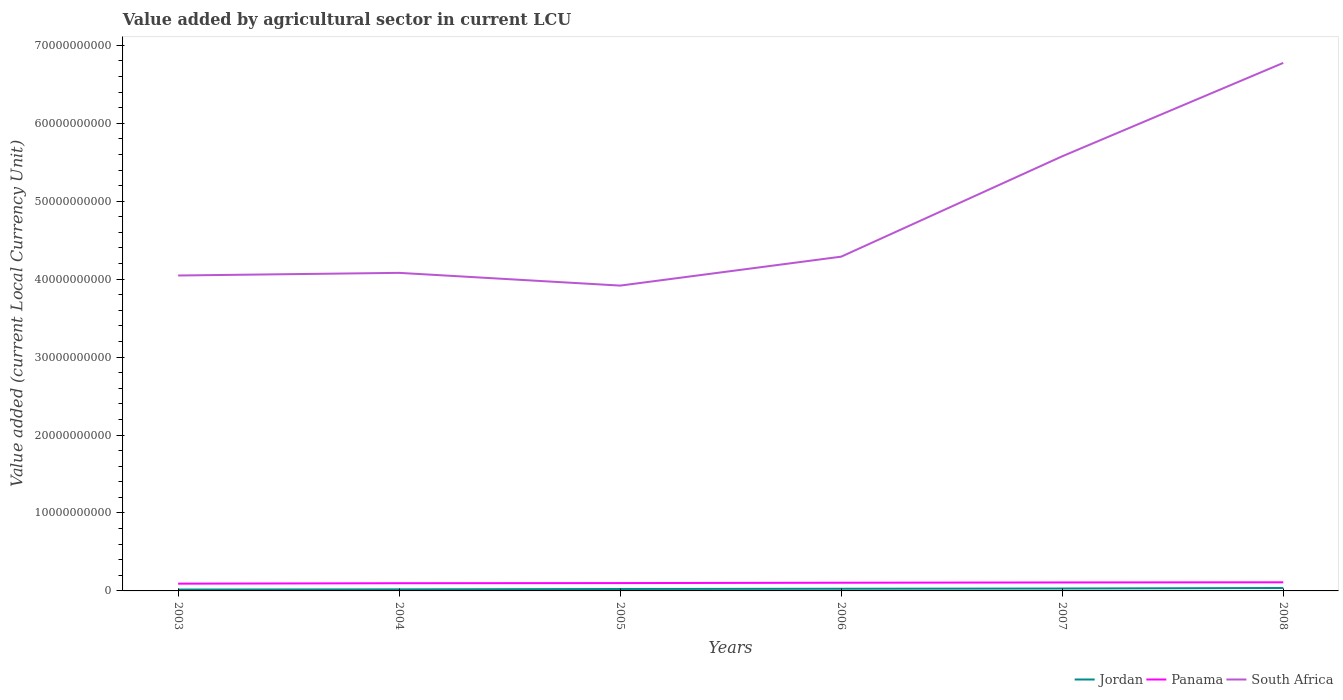Is the number of lines equal to the number of legend labels?
Make the answer very short. Yes. Across all years, what is the maximum value added by agricultural sector in South Africa?
Ensure brevity in your answer.  3.92e+1. What is the total value added by agricultural sector in Panama in the graph?
Your answer should be very brief. -1.77e+08. What is the difference between the highest and the second highest value added by agricultural sector in South Africa?
Provide a succinct answer. 2.86e+1. What is the difference between the highest and the lowest value added by agricultural sector in Panama?
Offer a very short reply. 3. How many years are there in the graph?
Provide a short and direct response. 6. What is the difference between two consecutive major ticks on the Y-axis?
Offer a terse response. 1.00e+1. Does the graph contain any zero values?
Ensure brevity in your answer.  No. Does the graph contain grids?
Keep it short and to the point. No. Where does the legend appear in the graph?
Give a very brief answer. Bottom right. How are the legend labels stacked?
Ensure brevity in your answer.  Horizontal. What is the title of the graph?
Ensure brevity in your answer.  Value added by agricultural sector in current LCU. What is the label or title of the Y-axis?
Keep it short and to the point. Value added (current Local Currency Unit). What is the Value added (current Local Currency Unit) in Jordan in 2003?
Provide a succinct answer. 1.78e+08. What is the Value added (current Local Currency Unit) of Panama in 2003?
Give a very brief answer. 9.30e+08. What is the Value added (current Local Currency Unit) in South Africa in 2003?
Keep it short and to the point. 4.05e+1. What is the Value added (current Local Currency Unit) in Jordan in 2004?
Provide a short and direct response. 2.02e+08. What is the Value added (current Local Currency Unit) of Panama in 2004?
Keep it short and to the point. 9.88e+08. What is the Value added (current Local Currency Unit) of South Africa in 2004?
Provide a short and direct response. 4.08e+1. What is the Value added (current Local Currency Unit) in Jordan in 2005?
Provide a short and direct response. 2.46e+08. What is the Value added (current Local Currency Unit) in Panama in 2005?
Your answer should be compact. 1.01e+09. What is the Value added (current Local Currency Unit) in South Africa in 2005?
Make the answer very short. 3.92e+1. What is the Value added (current Local Currency Unit) of Jordan in 2006?
Your answer should be compact. 2.76e+08. What is the Value added (current Local Currency Unit) of Panama in 2006?
Make the answer very short. 1.05e+09. What is the Value added (current Local Currency Unit) of South Africa in 2006?
Provide a succinct answer. 4.29e+1. What is the Value added (current Local Currency Unit) in Jordan in 2007?
Provide a succinct answer. 3.07e+08. What is the Value added (current Local Currency Unit) of Panama in 2007?
Give a very brief answer. 1.09e+09. What is the Value added (current Local Currency Unit) of South Africa in 2007?
Your answer should be very brief. 5.58e+1. What is the Value added (current Local Currency Unit) of Jordan in 2008?
Keep it short and to the point. 3.77e+08. What is the Value added (current Local Currency Unit) of Panama in 2008?
Ensure brevity in your answer.  1.11e+09. What is the Value added (current Local Currency Unit) in South Africa in 2008?
Your response must be concise. 6.77e+1. Across all years, what is the maximum Value added (current Local Currency Unit) of Jordan?
Ensure brevity in your answer.  3.77e+08. Across all years, what is the maximum Value added (current Local Currency Unit) in Panama?
Make the answer very short. 1.11e+09. Across all years, what is the maximum Value added (current Local Currency Unit) in South Africa?
Your response must be concise. 6.77e+1. Across all years, what is the minimum Value added (current Local Currency Unit) in Jordan?
Offer a terse response. 1.78e+08. Across all years, what is the minimum Value added (current Local Currency Unit) of Panama?
Make the answer very short. 9.30e+08. Across all years, what is the minimum Value added (current Local Currency Unit) in South Africa?
Provide a short and direct response. 3.92e+1. What is the total Value added (current Local Currency Unit) of Jordan in the graph?
Keep it short and to the point. 1.59e+09. What is the total Value added (current Local Currency Unit) of Panama in the graph?
Your response must be concise. 6.17e+09. What is the total Value added (current Local Currency Unit) of South Africa in the graph?
Your answer should be compact. 2.87e+11. What is the difference between the Value added (current Local Currency Unit) in Jordan in 2003 and that in 2004?
Your answer should be very brief. -2.37e+07. What is the difference between the Value added (current Local Currency Unit) of Panama in 2003 and that in 2004?
Offer a very short reply. -5.82e+07. What is the difference between the Value added (current Local Currency Unit) of South Africa in 2003 and that in 2004?
Your response must be concise. -3.39e+08. What is the difference between the Value added (current Local Currency Unit) in Jordan in 2003 and that in 2005?
Provide a short and direct response. -6.79e+07. What is the difference between the Value added (current Local Currency Unit) in Panama in 2003 and that in 2005?
Make the answer very short. -7.70e+07. What is the difference between the Value added (current Local Currency Unit) in South Africa in 2003 and that in 2005?
Ensure brevity in your answer.  1.29e+09. What is the difference between the Value added (current Local Currency Unit) in Jordan in 2003 and that in 2006?
Provide a short and direct response. -9.75e+07. What is the difference between the Value added (current Local Currency Unit) in Panama in 2003 and that in 2006?
Give a very brief answer. -1.20e+08. What is the difference between the Value added (current Local Currency Unit) of South Africa in 2003 and that in 2006?
Offer a terse response. -2.42e+09. What is the difference between the Value added (current Local Currency Unit) of Jordan in 2003 and that in 2007?
Provide a short and direct response. -1.29e+08. What is the difference between the Value added (current Local Currency Unit) of Panama in 2003 and that in 2007?
Offer a very short reply. -1.57e+08. What is the difference between the Value added (current Local Currency Unit) of South Africa in 2003 and that in 2007?
Give a very brief answer. -1.53e+1. What is the difference between the Value added (current Local Currency Unit) in Jordan in 2003 and that in 2008?
Offer a terse response. -1.98e+08. What is the difference between the Value added (current Local Currency Unit) of Panama in 2003 and that in 2008?
Your answer should be very brief. -1.77e+08. What is the difference between the Value added (current Local Currency Unit) of South Africa in 2003 and that in 2008?
Ensure brevity in your answer.  -2.73e+1. What is the difference between the Value added (current Local Currency Unit) of Jordan in 2004 and that in 2005?
Offer a terse response. -4.41e+07. What is the difference between the Value added (current Local Currency Unit) in Panama in 2004 and that in 2005?
Keep it short and to the point. -1.88e+07. What is the difference between the Value added (current Local Currency Unit) in South Africa in 2004 and that in 2005?
Give a very brief answer. 1.63e+09. What is the difference between the Value added (current Local Currency Unit) of Jordan in 2004 and that in 2006?
Your answer should be very brief. -7.38e+07. What is the difference between the Value added (current Local Currency Unit) in Panama in 2004 and that in 2006?
Provide a succinct answer. -6.20e+07. What is the difference between the Value added (current Local Currency Unit) of South Africa in 2004 and that in 2006?
Your answer should be very brief. -2.08e+09. What is the difference between the Value added (current Local Currency Unit) in Jordan in 2004 and that in 2007?
Your answer should be compact. -1.05e+08. What is the difference between the Value added (current Local Currency Unit) in Panama in 2004 and that in 2007?
Provide a short and direct response. -9.84e+07. What is the difference between the Value added (current Local Currency Unit) in South Africa in 2004 and that in 2007?
Make the answer very short. -1.50e+1. What is the difference between the Value added (current Local Currency Unit) of Jordan in 2004 and that in 2008?
Provide a short and direct response. -1.75e+08. What is the difference between the Value added (current Local Currency Unit) in Panama in 2004 and that in 2008?
Ensure brevity in your answer.  -1.19e+08. What is the difference between the Value added (current Local Currency Unit) of South Africa in 2004 and that in 2008?
Ensure brevity in your answer.  -2.69e+1. What is the difference between the Value added (current Local Currency Unit) in Jordan in 2005 and that in 2006?
Offer a terse response. -2.96e+07. What is the difference between the Value added (current Local Currency Unit) in Panama in 2005 and that in 2006?
Keep it short and to the point. -4.32e+07. What is the difference between the Value added (current Local Currency Unit) of South Africa in 2005 and that in 2006?
Keep it short and to the point. -3.71e+09. What is the difference between the Value added (current Local Currency Unit) of Jordan in 2005 and that in 2007?
Provide a short and direct response. -6.09e+07. What is the difference between the Value added (current Local Currency Unit) in Panama in 2005 and that in 2007?
Provide a short and direct response. -7.96e+07. What is the difference between the Value added (current Local Currency Unit) in South Africa in 2005 and that in 2007?
Provide a short and direct response. -1.66e+1. What is the difference between the Value added (current Local Currency Unit) of Jordan in 2005 and that in 2008?
Your answer should be very brief. -1.31e+08. What is the difference between the Value added (current Local Currency Unit) in Panama in 2005 and that in 2008?
Provide a short and direct response. -1.00e+08. What is the difference between the Value added (current Local Currency Unit) of South Africa in 2005 and that in 2008?
Offer a very short reply. -2.86e+1. What is the difference between the Value added (current Local Currency Unit) of Jordan in 2006 and that in 2007?
Provide a succinct answer. -3.13e+07. What is the difference between the Value added (current Local Currency Unit) of Panama in 2006 and that in 2007?
Give a very brief answer. -3.64e+07. What is the difference between the Value added (current Local Currency Unit) of South Africa in 2006 and that in 2007?
Keep it short and to the point. -1.29e+1. What is the difference between the Value added (current Local Currency Unit) of Jordan in 2006 and that in 2008?
Offer a very short reply. -1.01e+08. What is the difference between the Value added (current Local Currency Unit) in Panama in 2006 and that in 2008?
Provide a succinct answer. -5.68e+07. What is the difference between the Value added (current Local Currency Unit) of South Africa in 2006 and that in 2008?
Offer a terse response. -2.49e+1. What is the difference between the Value added (current Local Currency Unit) of Jordan in 2007 and that in 2008?
Give a very brief answer. -6.96e+07. What is the difference between the Value added (current Local Currency Unit) in Panama in 2007 and that in 2008?
Make the answer very short. -2.04e+07. What is the difference between the Value added (current Local Currency Unit) of South Africa in 2007 and that in 2008?
Keep it short and to the point. -1.20e+1. What is the difference between the Value added (current Local Currency Unit) of Jordan in 2003 and the Value added (current Local Currency Unit) of Panama in 2004?
Offer a terse response. -8.09e+08. What is the difference between the Value added (current Local Currency Unit) in Jordan in 2003 and the Value added (current Local Currency Unit) in South Africa in 2004?
Offer a terse response. -4.06e+1. What is the difference between the Value added (current Local Currency Unit) of Panama in 2003 and the Value added (current Local Currency Unit) of South Africa in 2004?
Offer a terse response. -3.99e+1. What is the difference between the Value added (current Local Currency Unit) of Jordan in 2003 and the Value added (current Local Currency Unit) of Panama in 2005?
Your answer should be very brief. -8.28e+08. What is the difference between the Value added (current Local Currency Unit) of Jordan in 2003 and the Value added (current Local Currency Unit) of South Africa in 2005?
Offer a very short reply. -3.90e+1. What is the difference between the Value added (current Local Currency Unit) of Panama in 2003 and the Value added (current Local Currency Unit) of South Africa in 2005?
Keep it short and to the point. -3.82e+1. What is the difference between the Value added (current Local Currency Unit) in Jordan in 2003 and the Value added (current Local Currency Unit) in Panama in 2006?
Ensure brevity in your answer.  -8.71e+08. What is the difference between the Value added (current Local Currency Unit) in Jordan in 2003 and the Value added (current Local Currency Unit) in South Africa in 2006?
Your response must be concise. -4.27e+1. What is the difference between the Value added (current Local Currency Unit) of Panama in 2003 and the Value added (current Local Currency Unit) of South Africa in 2006?
Ensure brevity in your answer.  -4.20e+1. What is the difference between the Value added (current Local Currency Unit) of Jordan in 2003 and the Value added (current Local Currency Unit) of Panama in 2007?
Your answer should be compact. -9.08e+08. What is the difference between the Value added (current Local Currency Unit) of Jordan in 2003 and the Value added (current Local Currency Unit) of South Africa in 2007?
Provide a succinct answer. -5.56e+1. What is the difference between the Value added (current Local Currency Unit) in Panama in 2003 and the Value added (current Local Currency Unit) in South Africa in 2007?
Make the answer very short. -5.48e+1. What is the difference between the Value added (current Local Currency Unit) of Jordan in 2003 and the Value added (current Local Currency Unit) of Panama in 2008?
Provide a succinct answer. -9.28e+08. What is the difference between the Value added (current Local Currency Unit) of Jordan in 2003 and the Value added (current Local Currency Unit) of South Africa in 2008?
Your answer should be very brief. -6.76e+1. What is the difference between the Value added (current Local Currency Unit) of Panama in 2003 and the Value added (current Local Currency Unit) of South Africa in 2008?
Your response must be concise. -6.68e+1. What is the difference between the Value added (current Local Currency Unit) in Jordan in 2004 and the Value added (current Local Currency Unit) in Panama in 2005?
Offer a terse response. -8.05e+08. What is the difference between the Value added (current Local Currency Unit) in Jordan in 2004 and the Value added (current Local Currency Unit) in South Africa in 2005?
Your response must be concise. -3.90e+1. What is the difference between the Value added (current Local Currency Unit) in Panama in 2004 and the Value added (current Local Currency Unit) in South Africa in 2005?
Provide a short and direct response. -3.82e+1. What is the difference between the Value added (current Local Currency Unit) in Jordan in 2004 and the Value added (current Local Currency Unit) in Panama in 2006?
Provide a short and direct response. -8.48e+08. What is the difference between the Value added (current Local Currency Unit) of Jordan in 2004 and the Value added (current Local Currency Unit) of South Africa in 2006?
Your response must be concise. -4.27e+1. What is the difference between the Value added (current Local Currency Unit) in Panama in 2004 and the Value added (current Local Currency Unit) in South Africa in 2006?
Give a very brief answer. -4.19e+1. What is the difference between the Value added (current Local Currency Unit) of Jordan in 2004 and the Value added (current Local Currency Unit) of Panama in 2007?
Provide a succinct answer. -8.84e+08. What is the difference between the Value added (current Local Currency Unit) of Jordan in 2004 and the Value added (current Local Currency Unit) of South Africa in 2007?
Ensure brevity in your answer.  -5.56e+1. What is the difference between the Value added (current Local Currency Unit) in Panama in 2004 and the Value added (current Local Currency Unit) in South Africa in 2007?
Your response must be concise. -5.48e+1. What is the difference between the Value added (current Local Currency Unit) in Jordan in 2004 and the Value added (current Local Currency Unit) in Panama in 2008?
Provide a succinct answer. -9.05e+08. What is the difference between the Value added (current Local Currency Unit) in Jordan in 2004 and the Value added (current Local Currency Unit) in South Africa in 2008?
Give a very brief answer. -6.75e+1. What is the difference between the Value added (current Local Currency Unit) of Panama in 2004 and the Value added (current Local Currency Unit) of South Africa in 2008?
Your response must be concise. -6.68e+1. What is the difference between the Value added (current Local Currency Unit) of Jordan in 2005 and the Value added (current Local Currency Unit) of Panama in 2006?
Your answer should be very brief. -8.04e+08. What is the difference between the Value added (current Local Currency Unit) in Jordan in 2005 and the Value added (current Local Currency Unit) in South Africa in 2006?
Keep it short and to the point. -4.26e+1. What is the difference between the Value added (current Local Currency Unit) of Panama in 2005 and the Value added (current Local Currency Unit) of South Africa in 2006?
Provide a succinct answer. -4.19e+1. What is the difference between the Value added (current Local Currency Unit) in Jordan in 2005 and the Value added (current Local Currency Unit) in Panama in 2007?
Make the answer very short. -8.40e+08. What is the difference between the Value added (current Local Currency Unit) of Jordan in 2005 and the Value added (current Local Currency Unit) of South Africa in 2007?
Your response must be concise. -5.55e+1. What is the difference between the Value added (current Local Currency Unit) of Panama in 2005 and the Value added (current Local Currency Unit) of South Africa in 2007?
Offer a terse response. -5.48e+1. What is the difference between the Value added (current Local Currency Unit) of Jordan in 2005 and the Value added (current Local Currency Unit) of Panama in 2008?
Ensure brevity in your answer.  -8.60e+08. What is the difference between the Value added (current Local Currency Unit) of Jordan in 2005 and the Value added (current Local Currency Unit) of South Africa in 2008?
Your response must be concise. -6.75e+1. What is the difference between the Value added (current Local Currency Unit) in Panama in 2005 and the Value added (current Local Currency Unit) in South Africa in 2008?
Make the answer very short. -6.67e+1. What is the difference between the Value added (current Local Currency Unit) in Jordan in 2006 and the Value added (current Local Currency Unit) in Panama in 2007?
Provide a succinct answer. -8.10e+08. What is the difference between the Value added (current Local Currency Unit) of Jordan in 2006 and the Value added (current Local Currency Unit) of South Africa in 2007?
Your answer should be compact. -5.55e+1. What is the difference between the Value added (current Local Currency Unit) of Panama in 2006 and the Value added (current Local Currency Unit) of South Africa in 2007?
Keep it short and to the point. -5.47e+1. What is the difference between the Value added (current Local Currency Unit) in Jordan in 2006 and the Value added (current Local Currency Unit) in Panama in 2008?
Your response must be concise. -8.31e+08. What is the difference between the Value added (current Local Currency Unit) in Jordan in 2006 and the Value added (current Local Currency Unit) in South Africa in 2008?
Your answer should be compact. -6.75e+1. What is the difference between the Value added (current Local Currency Unit) in Panama in 2006 and the Value added (current Local Currency Unit) in South Africa in 2008?
Keep it short and to the point. -6.67e+1. What is the difference between the Value added (current Local Currency Unit) of Jordan in 2007 and the Value added (current Local Currency Unit) of Panama in 2008?
Offer a terse response. -7.99e+08. What is the difference between the Value added (current Local Currency Unit) of Jordan in 2007 and the Value added (current Local Currency Unit) of South Africa in 2008?
Your answer should be very brief. -6.74e+1. What is the difference between the Value added (current Local Currency Unit) in Panama in 2007 and the Value added (current Local Currency Unit) in South Africa in 2008?
Provide a short and direct response. -6.67e+1. What is the average Value added (current Local Currency Unit) of Jordan per year?
Keep it short and to the point. 2.64e+08. What is the average Value added (current Local Currency Unit) of Panama per year?
Give a very brief answer. 1.03e+09. What is the average Value added (current Local Currency Unit) in South Africa per year?
Your answer should be very brief. 4.78e+1. In the year 2003, what is the difference between the Value added (current Local Currency Unit) in Jordan and Value added (current Local Currency Unit) in Panama?
Your answer should be very brief. -7.51e+08. In the year 2003, what is the difference between the Value added (current Local Currency Unit) of Jordan and Value added (current Local Currency Unit) of South Africa?
Provide a succinct answer. -4.03e+1. In the year 2003, what is the difference between the Value added (current Local Currency Unit) of Panama and Value added (current Local Currency Unit) of South Africa?
Ensure brevity in your answer.  -3.95e+1. In the year 2004, what is the difference between the Value added (current Local Currency Unit) in Jordan and Value added (current Local Currency Unit) in Panama?
Give a very brief answer. -7.86e+08. In the year 2004, what is the difference between the Value added (current Local Currency Unit) in Jordan and Value added (current Local Currency Unit) in South Africa?
Your response must be concise. -4.06e+1. In the year 2004, what is the difference between the Value added (current Local Currency Unit) in Panama and Value added (current Local Currency Unit) in South Africa?
Your answer should be compact. -3.98e+1. In the year 2005, what is the difference between the Value added (current Local Currency Unit) in Jordan and Value added (current Local Currency Unit) in Panama?
Offer a very short reply. -7.60e+08. In the year 2005, what is the difference between the Value added (current Local Currency Unit) of Jordan and Value added (current Local Currency Unit) of South Africa?
Ensure brevity in your answer.  -3.89e+1. In the year 2005, what is the difference between the Value added (current Local Currency Unit) in Panama and Value added (current Local Currency Unit) in South Africa?
Keep it short and to the point. -3.82e+1. In the year 2006, what is the difference between the Value added (current Local Currency Unit) in Jordan and Value added (current Local Currency Unit) in Panama?
Your response must be concise. -7.74e+08. In the year 2006, what is the difference between the Value added (current Local Currency Unit) in Jordan and Value added (current Local Currency Unit) in South Africa?
Your answer should be compact. -4.26e+1. In the year 2006, what is the difference between the Value added (current Local Currency Unit) of Panama and Value added (current Local Currency Unit) of South Africa?
Provide a succinct answer. -4.18e+1. In the year 2007, what is the difference between the Value added (current Local Currency Unit) of Jordan and Value added (current Local Currency Unit) of Panama?
Your answer should be compact. -7.79e+08. In the year 2007, what is the difference between the Value added (current Local Currency Unit) of Jordan and Value added (current Local Currency Unit) of South Africa?
Offer a terse response. -5.55e+1. In the year 2007, what is the difference between the Value added (current Local Currency Unit) in Panama and Value added (current Local Currency Unit) in South Africa?
Make the answer very short. -5.47e+1. In the year 2008, what is the difference between the Value added (current Local Currency Unit) in Jordan and Value added (current Local Currency Unit) in Panama?
Make the answer very short. -7.30e+08. In the year 2008, what is the difference between the Value added (current Local Currency Unit) of Jordan and Value added (current Local Currency Unit) of South Africa?
Offer a very short reply. -6.74e+1. In the year 2008, what is the difference between the Value added (current Local Currency Unit) in Panama and Value added (current Local Currency Unit) in South Africa?
Offer a terse response. -6.66e+1. What is the ratio of the Value added (current Local Currency Unit) of Jordan in 2003 to that in 2004?
Offer a very short reply. 0.88. What is the ratio of the Value added (current Local Currency Unit) in Panama in 2003 to that in 2004?
Offer a very short reply. 0.94. What is the ratio of the Value added (current Local Currency Unit) of Jordan in 2003 to that in 2005?
Keep it short and to the point. 0.72. What is the ratio of the Value added (current Local Currency Unit) of Panama in 2003 to that in 2005?
Your answer should be compact. 0.92. What is the ratio of the Value added (current Local Currency Unit) in South Africa in 2003 to that in 2005?
Your answer should be very brief. 1.03. What is the ratio of the Value added (current Local Currency Unit) of Jordan in 2003 to that in 2006?
Give a very brief answer. 0.65. What is the ratio of the Value added (current Local Currency Unit) of Panama in 2003 to that in 2006?
Keep it short and to the point. 0.89. What is the ratio of the Value added (current Local Currency Unit) of South Africa in 2003 to that in 2006?
Your answer should be compact. 0.94. What is the ratio of the Value added (current Local Currency Unit) in Jordan in 2003 to that in 2007?
Provide a short and direct response. 0.58. What is the ratio of the Value added (current Local Currency Unit) in Panama in 2003 to that in 2007?
Keep it short and to the point. 0.86. What is the ratio of the Value added (current Local Currency Unit) of South Africa in 2003 to that in 2007?
Provide a succinct answer. 0.73. What is the ratio of the Value added (current Local Currency Unit) in Jordan in 2003 to that in 2008?
Ensure brevity in your answer.  0.47. What is the ratio of the Value added (current Local Currency Unit) in Panama in 2003 to that in 2008?
Your answer should be very brief. 0.84. What is the ratio of the Value added (current Local Currency Unit) of South Africa in 2003 to that in 2008?
Offer a very short reply. 0.6. What is the ratio of the Value added (current Local Currency Unit) in Jordan in 2004 to that in 2005?
Offer a very short reply. 0.82. What is the ratio of the Value added (current Local Currency Unit) of Panama in 2004 to that in 2005?
Give a very brief answer. 0.98. What is the ratio of the Value added (current Local Currency Unit) in South Africa in 2004 to that in 2005?
Ensure brevity in your answer.  1.04. What is the ratio of the Value added (current Local Currency Unit) in Jordan in 2004 to that in 2006?
Make the answer very short. 0.73. What is the ratio of the Value added (current Local Currency Unit) of Panama in 2004 to that in 2006?
Offer a very short reply. 0.94. What is the ratio of the Value added (current Local Currency Unit) of South Africa in 2004 to that in 2006?
Give a very brief answer. 0.95. What is the ratio of the Value added (current Local Currency Unit) of Jordan in 2004 to that in 2007?
Your answer should be very brief. 0.66. What is the ratio of the Value added (current Local Currency Unit) of Panama in 2004 to that in 2007?
Keep it short and to the point. 0.91. What is the ratio of the Value added (current Local Currency Unit) of South Africa in 2004 to that in 2007?
Your answer should be compact. 0.73. What is the ratio of the Value added (current Local Currency Unit) of Jordan in 2004 to that in 2008?
Your response must be concise. 0.54. What is the ratio of the Value added (current Local Currency Unit) of Panama in 2004 to that in 2008?
Provide a short and direct response. 0.89. What is the ratio of the Value added (current Local Currency Unit) of South Africa in 2004 to that in 2008?
Make the answer very short. 0.6. What is the ratio of the Value added (current Local Currency Unit) in Jordan in 2005 to that in 2006?
Your answer should be compact. 0.89. What is the ratio of the Value added (current Local Currency Unit) of Panama in 2005 to that in 2006?
Provide a short and direct response. 0.96. What is the ratio of the Value added (current Local Currency Unit) in South Africa in 2005 to that in 2006?
Your answer should be very brief. 0.91. What is the ratio of the Value added (current Local Currency Unit) of Jordan in 2005 to that in 2007?
Provide a short and direct response. 0.8. What is the ratio of the Value added (current Local Currency Unit) of Panama in 2005 to that in 2007?
Ensure brevity in your answer.  0.93. What is the ratio of the Value added (current Local Currency Unit) in South Africa in 2005 to that in 2007?
Provide a short and direct response. 0.7. What is the ratio of the Value added (current Local Currency Unit) of Jordan in 2005 to that in 2008?
Make the answer very short. 0.65. What is the ratio of the Value added (current Local Currency Unit) in Panama in 2005 to that in 2008?
Give a very brief answer. 0.91. What is the ratio of the Value added (current Local Currency Unit) in South Africa in 2005 to that in 2008?
Your answer should be compact. 0.58. What is the ratio of the Value added (current Local Currency Unit) in Jordan in 2006 to that in 2007?
Your response must be concise. 0.9. What is the ratio of the Value added (current Local Currency Unit) of Panama in 2006 to that in 2007?
Your answer should be compact. 0.97. What is the ratio of the Value added (current Local Currency Unit) in South Africa in 2006 to that in 2007?
Your response must be concise. 0.77. What is the ratio of the Value added (current Local Currency Unit) in Jordan in 2006 to that in 2008?
Provide a short and direct response. 0.73. What is the ratio of the Value added (current Local Currency Unit) in Panama in 2006 to that in 2008?
Your response must be concise. 0.95. What is the ratio of the Value added (current Local Currency Unit) of South Africa in 2006 to that in 2008?
Make the answer very short. 0.63. What is the ratio of the Value added (current Local Currency Unit) of Jordan in 2007 to that in 2008?
Provide a short and direct response. 0.82. What is the ratio of the Value added (current Local Currency Unit) of Panama in 2007 to that in 2008?
Provide a short and direct response. 0.98. What is the ratio of the Value added (current Local Currency Unit) of South Africa in 2007 to that in 2008?
Offer a very short reply. 0.82. What is the difference between the highest and the second highest Value added (current Local Currency Unit) in Jordan?
Your answer should be very brief. 6.96e+07. What is the difference between the highest and the second highest Value added (current Local Currency Unit) of Panama?
Your answer should be compact. 2.04e+07. What is the difference between the highest and the second highest Value added (current Local Currency Unit) in South Africa?
Your response must be concise. 1.20e+1. What is the difference between the highest and the lowest Value added (current Local Currency Unit) in Jordan?
Make the answer very short. 1.98e+08. What is the difference between the highest and the lowest Value added (current Local Currency Unit) in Panama?
Provide a succinct answer. 1.77e+08. What is the difference between the highest and the lowest Value added (current Local Currency Unit) in South Africa?
Provide a succinct answer. 2.86e+1. 